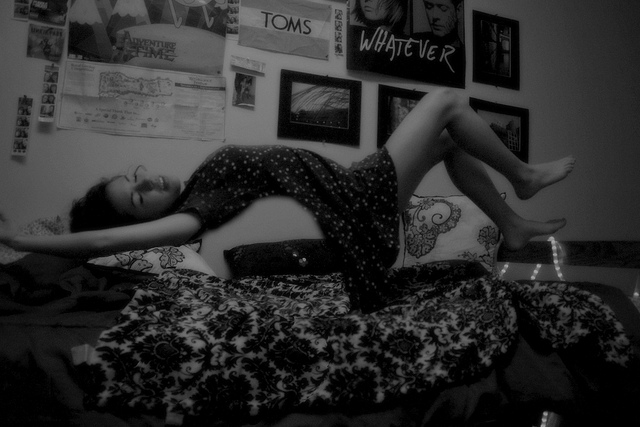<image>Who is this girl's sister? I don't know who this girl's sister is. It is not provided in the image. Who is this girl's sister? I don't know who is this girl's sister. It could be her sister, Tom's, Nancy, Meesha, or Annie. 